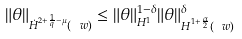<formula> <loc_0><loc_0><loc_500><loc_500>\| \theta \| _ { \dot { H } ^ { 2 + \frac { 1 } { q } - \mu } ( \ w ) } \leq \| \theta \| ^ { 1 - \delta } _ { H ^ { 1 } } \| \theta \| ^ { \delta } _ { H ^ { 1 + \frac { \alpha } { 2 } } ( \ w ) }</formula> 